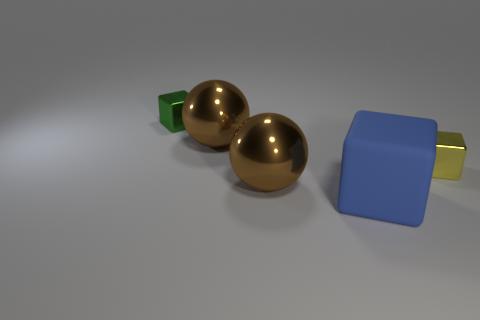Is there any other thing that is the same color as the big rubber object?
Provide a short and direct response. No. There is a cube that is on the left side of the rubber block; is it the same size as the blue cube?
Offer a terse response. No. What number of large brown objects are behind the shiny block that is on the right side of the green object?
Your response must be concise. 1. Are there any small shiny blocks that are to the left of the blue thing on the right side of the tiny green object behind the large block?
Your answer should be compact. Yes. There is a large thing that is the same shape as the small yellow shiny thing; what material is it?
Provide a succinct answer. Rubber. Is there any other thing that is made of the same material as the small green cube?
Your answer should be compact. Yes. Do the tiny green thing and the tiny object on the right side of the green thing have the same material?
Ensure brevity in your answer.  Yes. What shape is the big object that is right of the metal thing in front of the small yellow block?
Make the answer very short. Cube. What number of big things are either brown shiny objects or metallic blocks?
Ensure brevity in your answer.  2. How many yellow objects have the same shape as the green metallic object?
Your answer should be compact. 1. 